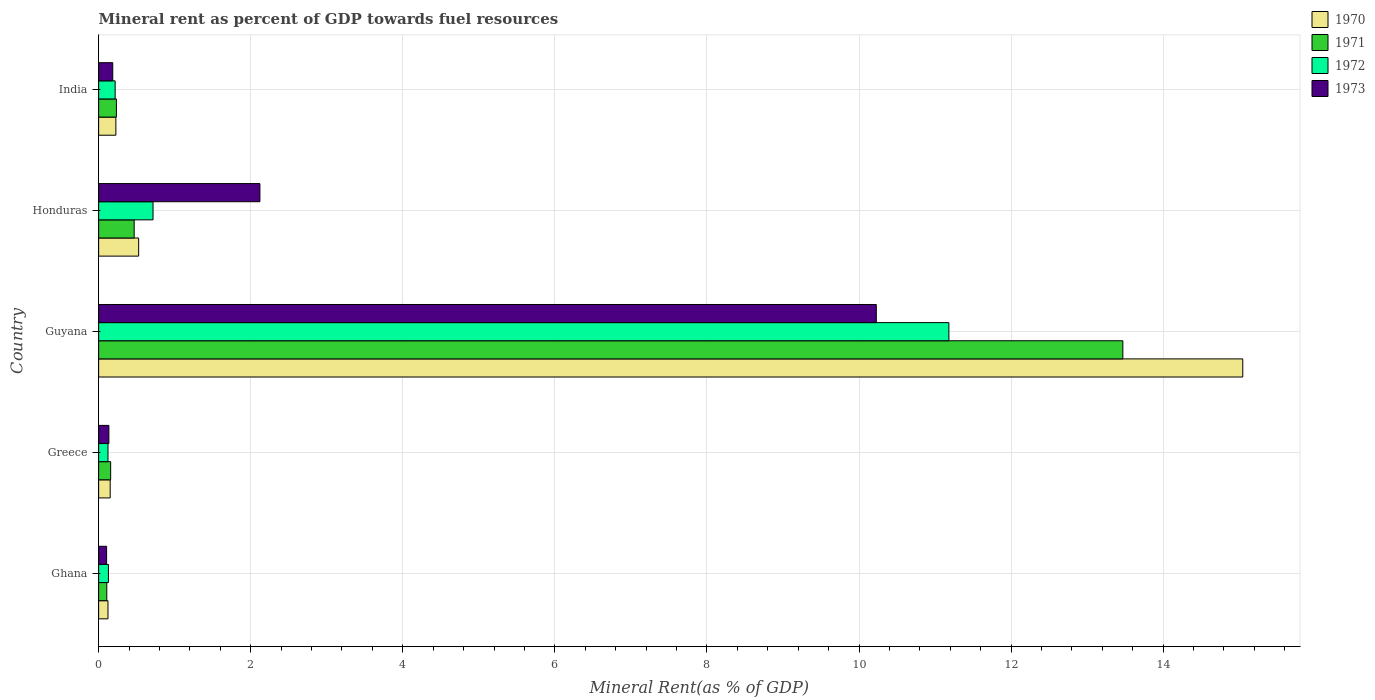How many different coloured bars are there?
Ensure brevity in your answer.  4. How many bars are there on the 4th tick from the top?
Provide a succinct answer. 4. How many bars are there on the 1st tick from the bottom?
Provide a short and direct response. 4. What is the label of the 3rd group of bars from the top?
Keep it short and to the point. Guyana. In how many cases, is the number of bars for a given country not equal to the number of legend labels?
Provide a short and direct response. 0. What is the mineral rent in 1971 in Ghana?
Provide a succinct answer. 0.11. Across all countries, what is the maximum mineral rent in 1972?
Provide a short and direct response. 11.18. Across all countries, what is the minimum mineral rent in 1971?
Offer a very short reply. 0.11. In which country was the mineral rent in 1971 maximum?
Ensure brevity in your answer.  Guyana. In which country was the mineral rent in 1971 minimum?
Provide a succinct answer. Ghana. What is the total mineral rent in 1970 in the graph?
Offer a very short reply. 16.08. What is the difference between the mineral rent in 1970 in Ghana and that in Honduras?
Keep it short and to the point. -0.4. What is the difference between the mineral rent in 1972 in India and the mineral rent in 1970 in Honduras?
Provide a short and direct response. -0.31. What is the average mineral rent in 1972 per country?
Make the answer very short. 2.47. What is the difference between the mineral rent in 1973 and mineral rent in 1970 in Honduras?
Offer a very short reply. 1.59. What is the ratio of the mineral rent in 1973 in Ghana to that in Greece?
Your answer should be very brief. 0.78. What is the difference between the highest and the second highest mineral rent in 1970?
Provide a succinct answer. 14.52. What is the difference between the highest and the lowest mineral rent in 1973?
Your response must be concise. 10.12. In how many countries, is the mineral rent in 1973 greater than the average mineral rent in 1973 taken over all countries?
Offer a terse response. 1. Is the sum of the mineral rent in 1970 in Ghana and Honduras greater than the maximum mineral rent in 1972 across all countries?
Give a very brief answer. No. What does the 3rd bar from the top in Greece represents?
Make the answer very short. 1971. What does the 2nd bar from the bottom in Honduras represents?
Offer a terse response. 1971. Is it the case that in every country, the sum of the mineral rent in 1971 and mineral rent in 1972 is greater than the mineral rent in 1970?
Provide a succinct answer. Yes. How many countries are there in the graph?
Offer a terse response. 5. What is the difference between two consecutive major ticks on the X-axis?
Make the answer very short. 2. Are the values on the major ticks of X-axis written in scientific E-notation?
Your response must be concise. No. Where does the legend appear in the graph?
Ensure brevity in your answer.  Top right. How many legend labels are there?
Provide a succinct answer. 4. What is the title of the graph?
Provide a short and direct response. Mineral rent as percent of GDP towards fuel resources. Does "1971" appear as one of the legend labels in the graph?
Your answer should be very brief. Yes. What is the label or title of the X-axis?
Your answer should be compact. Mineral Rent(as % of GDP). What is the label or title of the Y-axis?
Provide a succinct answer. Country. What is the Mineral Rent(as % of GDP) of 1970 in Ghana?
Provide a succinct answer. 0.12. What is the Mineral Rent(as % of GDP) of 1971 in Ghana?
Your answer should be compact. 0.11. What is the Mineral Rent(as % of GDP) in 1972 in Ghana?
Provide a succinct answer. 0.13. What is the Mineral Rent(as % of GDP) of 1973 in Ghana?
Offer a terse response. 0.1. What is the Mineral Rent(as % of GDP) of 1970 in Greece?
Your answer should be compact. 0.15. What is the Mineral Rent(as % of GDP) in 1971 in Greece?
Give a very brief answer. 0.16. What is the Mineral Rent(as % of GDP) of 1972 in Greece?
Your answer should be very brief. 0.12. What is the Mineral Rent(as % of GDP) in 1973 in Greece?
Offer a terse response. 0.13. What is the Mineral Rent(as % of GDP) in 1970 in Guyana?
Your answer should be compact. 15.05. What is the Mineral Rent(as % of GDP) in 1971 in Guyana?
Ensure brevity in your answer.  13.47. What is the Mineral Rent(as % of GDP) of 1972 in Guyana?
Your response must be concise. 11.18. What is the Mineral Rent(as % of GDP) of 1973 in Guyana?
Your answer should be very brief. 10.23. What is the Mineral Rent(as % of GDP) of 1970 in Honduras?
Ensure brevity in your answer.  0.53. What is the Mineral Rent(as % of GDP) in 1971 in Honduras?
Your answer should be compact. 0.47. What is the Mineral Rent(as % of GDP) in 1972 in Honduras?
Offer a terse response. 0.72. What is the Mineral Rent(as % of GDP) of 1973 in Honduras?
Provide a short and direct response. 2.12. What is the Mineral Rent(as % of GDP) in 1970 in India?
Keep it short and to the point. 0.23. What is the Mineral Rent(as % of GDP) in 1971 in India?
Make the answer very short. 0.23. What is the Mineral Rent(as % of GDP) in 1972 in India?
Keep it short and to the point. 0.22. What is the Mineral Rent(as % of GDP) of 1973 in India?
Your answer should be compact. 0.19. Across all countries, what is the maximum Mineral Rent(as % of GDP) of 1970?
Your answer should be compact. 15.05. Across all countries, what is the maximum Mineral Rent(as % of GDP) in 1971?
Keep it short and to the point. 13.47. Across all countries, what is the maximum Mineral Rent(as % of GDP) in 1972?
Make the answer very short. 11.18. Across all countries, what is the maximum Mineral Rent(as % of GDP) in 1973?
Offer a very short reply. 10.23. Across all countries, what is the minimum Mineral Rent(as % of GDP) of 1970?
Ensure brevity in your answer.  0.12. Across all countries, what is the minimum Mineral Rent(as % of GDP) in 1971?
Ensure brevity in your answer.  0.11. Across all countries, what is the minimum Mineral Rent(as % of GDP) of 1972?
Offer a terse response. 0.12. Across all countries, what is the minimum Mineral Rent(as % of GDP) of 1973?
Your answer should be compact. 0.1. What is the total Mineral Rent(as % of GDP) in 1970 in the graph?
Provide a succinct answer. 16.08. What is the total Mineral Rent(as % of GDP) in 1971 in the graph?
Ensure brevity in your answer.  14.44. What is the total Mineral Rent(as % of GDP) in 1972 in the graph?
Your answer should be compact. 12.37. What is the total Mineral Rent(as % of GDP) in 1973 in the graph?
Provide a short and direct response. 12.77. What is the difference between the Mineral Rent(as % of GDP) of 1970 in Ghana and that in Greece?
Offer a terse response. -0.03. What is the difference between the Mineral Rent(as % of GDP) of 1971 in Ghana and that in Greece?
Provide a short and direct response. -0.05. What is the difference between the Mineral Rent(as % of GDP) of 1972 in Ghana and that in Greece?
Provide a short and direct response. 0.01. What is the difference between the Mineral Rent(as % of GDP) in 1973 in Ghana and that in Greece?
Make the answer very short. -0.03. What is the difference between the Mineral Rent(as % of GDP) of 1970 in Ghana and that in Guyana?
Give a very brief answer. -14.92. What is the difference between the Mineral Rent(as % of GDP) of 1971 in Ghana and that in Guyana?
Provide a succinct answer. -13.36. What is the difference between the Mineral Rent(as % of GDP) of 1972 in Ghana and that in Guyana?
Your response must be concise. -11.05. What is the difference between the Mineral Rent(as % of GDP) of 1973 in Ghana and that in Guyana?
Provide a short and direct response. -10.12. What is the difference between the Mineral Rent(as % of GDP) of 1970 in Ghana and that in Honduras?
Offer a terse response. -0.4. What is the difference between the Mineral Rent(as % of GDP) in 1971 in Ghana and that in Honduras?
Provide a succinct answer. -0.36. What is the difference between the Mineral Rent(as % of GDP) of 1972 in Ghana and that in Honduras?
Provide a succinct answer. -0.59. What is the difference between the Mineral Rent(as % of GDP) of 1973 in Ghana and that in Honduras?
Your answer should be very brief. -2.02. What is the difference between the Mineral Rent(as % of GDP) of 1970 in Ghana and that in India?
Your response must be concise. -0.1. What is the difference between the Mineral Rent(as % of GDP) in 1971 in Ghana and that in India?
Your answer should be compact. -0.13. What is the difference between the Mineral Rent(as % of GDP) in 1972 in Ghana and that in India?
Your answer should be very brief. -0.09. What is the difference between the Mineral Rent(as % of GDP) in 1973 in Ghana and that in India?
Your answer should be compact. -0.08. What is the difference between the Mineral Rent(as % of GDP) of 1970 in Greece and that in Guyana?
Your response must be concise. -14.9. What is the difference between the Mineral Rent(as % of GDP) of 1971 in Greece and that in Guyana?
Provide a succinct answer. -13.31. What is the difference between the Mineral Rent(as % of GDP) in 1972 in Greece and that in Guyana?
Offer a very short reply. -11.06. What is the difference between the Mineral Rent(as % of GDP) of 1973 in Greece and that in Guyana?
Provide a short and direct response. -10.09. What is the difference between the Mineral Rent(as % of GDP) in 1970 in Greece and that in Honduras?
Offer a very short reply. -0.37. What is the difference between the Mineral Rent(as % of GDP) of 1971 in Greece and that in Honduras?
Your answer should be compact. -0.31. What is the difference between the Mineral Rent(as % of GDP) in 1972 in Greece and that in Honduras?
Your answer should be very brief. -0.59. What is the difference between the Mineral Rent(as % of GDP) in 1973 in Greece and that in Honduras?
Offer a terse response. -1.99. What is the difference between the Mineral Rent(as % of GDP) of 1970 in Greece and that in India?
Keep it short and to the point. -0.07. What is the difference between the Mineral Rent(as % of GDP) in 1971 in Greece and that in India?
Offer a terse response. -0.08. What is the difference between the Mineral Rent(as % of GDP) of 1972 in Greece and that in India?
Ensure brevity in your answer.  -0.09. What is the difference between the Mineral Rent(as % of GDP) of 1973 in Greece and that in India?
Provide a succinct answer. -0.05. What is the difference between the Mineral Rent(as % of GDP) in 1970 in Guyana and that in Honduras?
Your response must be concise. 14.52. What is the difference between the Mineral Rent(as % of GDP) of 1971 in Guyana and that in Honduras?
Ensure brevity in your answer.  13. What is the difference between the Mineral Rent(as % of GDP) of 1972 in Guyana and that in Honduras?
Your answer should be very brief. 10.47. What is the difference between the Mineral Rent(as % of GDP) of 1973 in Guyana and that in Honduras?
Ensure brevity in your answer.  8.11. What is the difference between the Mineral Rent(as % of GDP) of 1970 in Guyana and that in India?
Keep it short and to the point. 14.82. What is the difference between the Mineral Rent(as % of GDP) in 1971 in Guyana and that in India?
Give a very brief answer. 13.24. What is the difference between the Mineral Rent(as % of GDP) of 1972 in Guyana and that in India?
Ensure brevity in your answer.  10.96. What is the difference between the Mineral Rent(as % of GDP) of 1973 in Guyana and that in India?
Your answer should be compact. 10.04. What is the difference between the Mineral Rent(as % of GDP) in 1970 in Honduras and that in India?
Ensure brevity in your answer.  0.3. What is the difference between the Mineral Rent(as % of GDP) of 1971 in Honduras and that in India?
Your answer should be very brief. 0.23. What is the difference between the Mineral Rent(as % of GDP) of 1972 in Honduras and that in India?
Offer a very short reply. 0.5. What is the difference between the Mineral Rent(as % of GDP) of 1973 in Honduras and that in India?
Your answer should be compact. 1.94. What is the difference between the Mineral Rent(as % of GDP) of 1970 in Ghana and the Mineral Rent(as % of GDP) of 1971 in Greece?
Offer a terse response. -0.04. What is the difference between the Mineral Rent(as % of GDP) in 1970 in Ghana and the Mineral Rent(as % of GDP) in 1973 in Greece?
Make the answer very short. -0.01. What is the difference between the Mineral Rent(as % of GDP) in 1971 in Ghana and the Mineral Rent(as % of GDP) in 1972 in Greece?
Give a very brief answer. -0.02. What is the difference between the Mineral Rent(as % of GDP) in 1971 in Ghana and the Mineral Rent(as % of GDP) in 1973 in Greece?
Offer a very short reply. -0.03. What is the difference between the Mineral Rent(as % of GDP) in 1972 in Ghana and the Mineral Rent(as % of GDP) in 1973 in Greece?
Provide a succinct answer. -0.01. What is the difference between the Mineral Rent(as % of GDP) of 1970 in Ghana and the Mineral Rent(as % of GDP) of 1971 in Guyana?
Give a very brief answer. -13.35. What is the difference between the Mineral Rent(as % of GDP) of 1970 in Ghana and the Mineral Rent(as % of GDP) of 1972 in Guyana?
Your answer should be compact. -11.06. What is the difference between the Mineral Rent(as % of GDP) in 1970 in Ghana and the Mineral Rent(as % of GDP) in 1973 in Guyana?
Ensure brevity in your answer.  -10.1. What is the difference between the Mineral Rent(as % of GDP) of 1971 in Ghana and the Mineral Rent(as % of GDP) of 1972 in Guyana?
Your answer should be compact. -11.07. What is the difference between the Mineral Rent(as % of GDP) in 1971 in Ghana and the Mineral Rent(as % of GDP) in 1973 in Guyana?
Provide a succinct answer. -10.12. What is the difference between the Mineral Rent(as % of GDP) of 1972 in Ghana and the Mineral Rent(as % of GDP) of 1973 in Guyana?
Ensure brevity in your answer.  -10.1. What is the difference between the Mineral Rent(as % of GDP) of 1970 in Ghana and the Mineral Rent(as % of GDP) of 1971 in Honduras?
Your answer should be compact. -0.34. What is the difference between the Mineral Rent(as % of GDP) in 1970 in Ghana and the Mineral Rent(as % of GDP) in 1972 in Honduras?
Make the answer very short. -0.59. What is the difference between the Mineral Rent(as % of GDP) of 1970 in Ghana and the Mineral Rent(as % of GDP) of 1973 in Honduras?
Give a very brief answer. -2. What is the difference between the Mineral Rent(as % of GDP) of 1971 in Ghana and the Mineral Rent(as % of GDP) of 1972 in Honduras?
Offer a terse response. -0.61. What is the difference between the Mineral Rent(as % of GDP) in 1971 in Ghana and the Mineral Rent(as % of GDP) in 1973 in Honduras?
Offer a terse response. -2.01. What is the difference between the Mineral Rent(as % of GDP) of 1972 in Ghana and the Mineral Rent(as % of GDP) of 1973 in Honduras?
Offer a terse response. -1.99. What is the difference between the Mineral Rent(as % of GDP) of 1970 in Ghana and the Mineral Rent(as % of GDP) of 1971 in India?
Offer a terse response. -0.11. What is the difference between the Mineral Rent(as % of GDP) in 1970 in Ghana and the Mineral Rent(as % of GDP) in 1972 in India?
Your answer should be compact. -0.09. What is the difference between the Mineral Rent(as % of GDP) in 1970 in Ghana and the Mineral Rent(as % of GDP) in 1973 in India?
Your answer should be compact. -0.06. What is the difference between the Mineral Rent(as % of GDP) in 1971 in Ghana and the Mineral Rent(as % of GDP) in 1972 in India?
Provide a short and direct response. -0.11. What is the difference between the Mineral Rent(as % of GDP) in 1971 in Ghana and the Mineral Rent(as % of GDP) in 1973 in India?
Give a very brief answer. -0.08. What is the difference between the Mineral Rent(as % of GDP) in 1972 in Ghana and the Mineral Rent(as % of GDP) in 1973 in India?
Offer a very short reply. -0.06. What is the difference between the Mineral Rent(as % of GDP) of 1970 in Greece and the Mineral Rent(as % of GDP) of 1971 in Guyana?
Your answer should be very brief. -13.32. What is the difference between the Mineral Rent(as % of GDP) of 1970 in Greece and the Mineral Rent(as % of GDP) of 1972 in Guyana?
Keep it short and to the point. -11.03. What is the difference between the Mineral Rent(as % of GDP) of 1970 in Greece and the Mineral Rent(as % of GDP) of 1973 in Guyana?
Your answer should be very brief. -10.08. What is the difference between the Mineral Rent(as % of GDP) of 1971 in Greece and the Mineral Rent(as % of GDP) of 1972 in Guyana?
Offer a very short reply. -11.02. What is the difference between the Mineral Rent(as % of GDP) in 1971 in Greece and the Mineral Rent(as % of GDP) in 1973 in Guyana?
Offer a terse response. -10.07. What is the difference between the Mineral Rent(as % of GDP) in 1972 in Greece and the Mineral Rent(as % of GDP) in 1973 in Guyana?
Your answer should be compact. -10.1. What is the difference between the Mineral Rent(as % of GDP) of 1970 in Greece and the Mineral Rent(as % of GDP) of 1971 in Honduras?
Offer a terse response. -0.32. What is the difference between the Mineral Rent(as % of GDP) in 1970 in Greece and the Mineral Rent(as % of GDP) in 1972 in Honduras?
Keep it short and to the point. -0.56. What is the difference between the Mineral Rent(as % of GDP) in 1970 in Greece and the Mineral Rent(as % of GDP) in 1973 in Honduras?
Ensure brevity in your answer.  -1.97. What is the difference between the Mineral Rent(as % of GDP) in 1971 in Greece and the Mineral Rent(as % of GDP) in 1972 in Honduras?
Your answer should be very brief. -0.56. What is the difference between the Mineral Rent(as % of GDP) in 1971 in Greece and the Mineral Rent(as % of GDP) in 1973 in Honduras?
Provide a succinct answer. -1.96. What is the difference between the Mineral Rent(as % of GDP) in 1972 in Greece and the Mineral Rent(as % of GDP) in 1973 in Honduras?
Provide a short and direct response. -2. What is the difference between the Mineral Rent(as % of GDP) in 1970 in Greece and the Mineral Rent(as % of GDP) in 1971 in India?
Provide a succinct answer. -0.08. What is the difference between the Mineral Rent(as % of GDP) in 1970 in Greece and the Mineral Rent(as % of GDP) in 1972 in India?
Your answer should be compact. -0.07. What is the difference between the Mineral Rent(as % of GDP) of 1970 in Greece and the Mineral Rent(as % of GDP) of 1973 in India?
Provide a succinct answer. -0.03. What is the difference between the Mineral Rent(as % of GDP) in 1971 in Greece and the Mineral Rent(as % of GDP) in 1972 in India?
Provide a succinct answer. -0.06. What is the difference between the Mineral Rent(as % of GDP) in 1971 in Greece and the Mineral Rent(as % of GDP) in 1973 in India?
Your response must be concise. -0.03. What is the difference between the Mineral Rent(as % of GDP) of 1972 in Greece and the Mineral Rent(as % of GDP) of 1973 in India?
Your response must be concise. -0.06. What is the difference between the Mineral Rent(as % of GDP) of 1970 in Guyana and the Mineral Rent(as % of GDP) of 1971 in Honduras?
Provide a short and direct response. 14.58. What is the difference between the Mineral Rent(as % of GDP) of 1970 in Guyana and the Mineral Rent(as % of GDP) of 1972 in Honduras?
Your answer should be compact. 14.33. What is the difference between the Mineral Rent(as % of GDP) of 1970 in Guyana and the Mineral Rent(as % of GDP) of 1973 in Honduras?
Offer a terse response. 12.93. What is the difference between the Mineral Rent(as % of GDP) in 1971 in Guyana and the Mineral Rent(as % of GDP) in 1972 in Honduras?
Your answer should be compact. 12.75. What is the difference between the Mineral Rent(as % of GDP) in 1971 in Guyana and the Mineral Rent(as % of GDP) in 1973 in Honduras?
Keep it short and to the point. 11.35. What is the difference between the Mineral Rent(as % of GDP) in 1972 in Guyana and the Mineral Rent(as % of GDP) in 1973 in Honduras?
Ensure brevity in your answer.  9.06. What is the difference between the Mineral Rent(as % of GDP) in 1970 in Guyana and the Mineral Rent(as % of GDP) in 1971 in India?
Your response must be concise. 14.81. What is the difference between the Mineral Rent(as % of GDP) of 1970 in Guyana and the Mineral Rent(as % of GDP) of 1972 in India?
Provide a succinct answer. 14.83. What is the difference between the Mineral Rent(as % of GDP) in 1970 in Guyana and the Mineral Rent(as % of GDP) in 1973 in India?
Ensure brevity in your answer.  14.86. What is the difference between the Mineral Rent(as % of GDP) in 1971 in Guyana and the Mineral Rent(as % of GDP) in 1972 in India?
Make the answer very short. 13.25. What is the difference between the Mineral Rent(as % of GDP) of 1971 in Guyana and the Mineral Rent(as % of GDP) of 1973 in India?
Provide a short and direct response. 13.28. What is the difference between the Mineral Rent(as % of GDP) in 1972 in Guyana and the Mineral Rent(as % of GDP) in 1973 in India?
Make the answer very short. 11. What is the difference between the Mineral Rent(as % of GDP) in 1970 in Honduras and the Mineral Rent(as % of GDP) in 1971 in India?
Keep it short and to the point. 0.29. What is the difference between the Mineral Rent(as % of GDP) of 1970 in Honduras and the Mineral Rent(as % of GDP) of 1972 in India?
Make the answer very short. 0.31. What is the difference between the Mineral Rent(as % of GDP) in 1970 in Honduras and the Mineral Rent(as % of GDP) in 1973 in India?
Your answer should be very brief. 0.34. What is the difference between the Mineral Rent(as % of GDP) in 1971 in Honduras and the Mineral Rent(as % of GDP) in 1972 in India?
Your answer should be compact. 0.25. What is the difference between the Mineral Rent(as % of GDP) in 1971 in Honduras and the Mineral Rent(as % of GDP) in 1973 in India?
Provide a short and direct response. 0.28. What is the difference between the Mineral Rent(as % of GDP) of 1972 in Honduras and the Mineral Rent(as % of GDP) of 1973 in India?
Keep it short and to the point. 0.53. What is the average Mineral Rent(as % of GDP) of 1970 per country?
Offer a very short reply. 3.22. What is the average Mineral Rent(as % of GDP) in 1971 per country?
Your answer should be very brief. 2.89. What is the average Mineral Rent(as % of GDP) in 1972 per country?
Your answer should be very brief. 2.47. What is the average Mineral Rent(as % of GDP) of 1973 per country?
Ensure brevity in your answer.  2.55. What is the difference between the Mineral Rent(as % of GDP) in 1970 and Mineral Rent(as % of GDP) in 1971 in Ghana?
Offer a terse response. 0.02. What is the difference between the Mineral Rent(as % of GDP) of 1970 and Mineral Rent(as % of GDP) of 1972 in Ghana?
Keep it short and to the point. -0.01. What is the difference between the Mineral Rent(as % of GDP) in 1970 and Mineral Rent(as % of GDP) in 1973 in Ghana?
Your response must be concise. 0.02. What is the difference between the Mineral Rent(as % of GDP) in 1971 and Mineral Rent(as % of GDP) in 1972 in Ghana?
Provide a short and direct response. -0.02. What is the difference between the Mineral Rent(as % of GDP) of 1971 and Mineral Rent(as % of GDP) of 1973 in Ghana?
Your answer should be very brief. 0. What is the difference between the Mineral Rent(as % of GDP) of 1972 and Mineral Rent(as % of GDP) of 1973 in Ghana?
Your answer should be compact. 0.02. What is the difference between the Mineral Rent(as % of GDP) in 1970 and Mineral Rent(as % of GDP) in 1971 in Greece?
Provide a succinct answer. -0.01. What is the difference between the Mineral Rent(as % of GDP) of 1970 and Mineral Rent(as % of GDP) of 1972 in Greece?
Give a very brief answer. 0.03. What is the difference between the Mineral Rent(as % of GDP) of 1970 and Mineral Rent(as % of GDP) of 1973 in Greece?
Keep it short and to the point. 0.02. What is the difference between the Mineral Rent(as % of GDP) of 1971 and Mineral Rent(as % of GDP) of 1972 in Greece?
Ensure brevity in your answer.  0.04. What is the difference between the Mineral Rent(as % of GDP) in 1971 and Mineral Rent(as % of GDP) in 1973 in Greece?
Give a very brief answer. 0.02. What is the difference between the Mineral Rent(as % of GDP) in 1972 and Mineral Rent(as % of GDP) in 1973 in Greece?
Offer a very short reply. -0.01. What is the difference between the Mineral Rent(as % of GDP) in 1970 and Mineral Rent(as % of GDP) in 1971 in Guyana?
Your answer should be very brief. 1.58. What is the difference between the Mineral Rent(as % of GDP) in 1970 and Mineral Rent(as % of GDP) in 1972 in Guyana?
Your answer should be very brief. 3.87. What is the difference between the Mineral Rent(as % of GDP) of 1970 and Mineral Rent(as % of GDP) of 1973 in Guyana?
Give a very brief answer. 4.82. What is the difference between the Mineral Rent(as % of GDP) of 1971 and Mineral Rent(as % of GDP) of 1972 in Guyana?
Provide a succinct answer. 2.29. What is the difference between the Mineral Rent(as % of GDP) of 1971 and Mineral Rent(as % of GDP) of 1973 in Guyana?
Provide a succinct answer. 3.24. What is the difference between the Mineral Rent(as % of GDP) of 1972 and Mineral Rent(as % of GDP) of 1973 in Guyana?
Your answer should be compact. 0.95. What is the difference between the Mineral Rent(as % of GDP) of 1970 and Mineral Rent(as % of GDP) of 1971 in Honduras?
Provide a succinct answer. 0.06. What is the difference between the Mineral Rent(as % of GDP) of 1970 and Mineral Rent(as % of GDP) of 1972 in Honduras?
Offer a very short reply. -0.19. What is the difference between the Mineral Rent(as % of GDP) of 1970 and Mineral Rent(as % of GDP) of 1973 in Honduras?
Your answer should be very brief. -1.59. What is the difference between the Mineral Rent(as % of GDP) of 1971 and Mineral Rent(as % of GDP) of 1972 in Honduras?
Offer a terse response. -0.25. What is the difference between the Mineral Rent(as % of GDP) in 1971 and Mineral Rent(as % of GDP) in 1973 in Honduras?
Your response must be concise. -1.65. What is the difference between the Mineral Rent(as % of GDP) of 1972 and Mineral Rent(as % of GDP) of 1973 in Honduras?
Ensure brevity in your answer.  -1.41. What is the difference between the Mineral Rent(as % of GDP) of 1970 and Mineral Rent(as % of GDP) of 1971 in India?
Offer a very short reply. -0.01. What is the difference between the Mineral Rent(as % of GDP) of 1970 and Mineral Rent(as % of GDP) of 1972 in India?
Your answer should be compact. 0.01. What is the difference between the Mineral Rent(as % of GDP) of 1970 and Mineral Rent(as % of GDP) of 1973 in India?
Keep it short and to the point. 0.04. What is the difference between the Mineral Rent(as % of GDP) of 1971 and Mineral Rent(as % of GDP) of 1972 in India?
Make the answer very short. 0.02. What is the difference between the Mineral Rent(as % of GDP) in 1971 and Mineral Rent(as % of GDP) in 1973 in India?
Make the answer very short. 0.05. What is the difference between the Mineral Rent(as % of GDP) in 1972 and Mineral Rent(as % of GDP) in 1973 in India?
Your response must be concise. 0.03. What is the ratio of the Mineral Rent(as % of GDP) in 1970 in Ghana to that in Greece?
Your answer should be compact. 0.81. What is the ratio of the Mineral Rent(as % of GDP) in 1971 in Ghana to that in Greece?
Offer a terse response. 0.68. What is the ratio of the Mineral Rent(as % of GDP) of 1972 in Ghana to that in Greece?
Provide a short and direct response. 1.05. What is the ratio of the Mineral Rent(as % of GDP) of 1973 in Ghana to that in Greece?
Provide a short and direct response. 0.78. What is the ratio of the Mineral Rent(as % of GDP) of 1970 in Ghana to that in Guyana?
Offer a terse response. 0.01. What is the ratio of the Mineral Rent(as % of GDP) in 1971 in Ghana to that in Guyana?
Keep it short and to the point. 0.01. What is the ratio of the Mineral Rent(as % of GDP) of 1972 in Ghana to that in Guyana?
Your answer should be very brief. 0.01. What is the ratio of the Mineral Rent(as % of GDP) of 1973 in Ghana to that in Guyana?
Your response must be concise. 0.01. What is the ratio of the Mineral Rent(as % of GDP) in 1970 in Ghana to that in Honduras?
Give a very brief answer. 0.23. What is the ratio of the Mineral Rent(as % of GDP) in 1971 in Ghana to that in Honduras?
Offer a terse response. 0.23. What is the ratio of the Mineral Rent(as % of GDP) of 1972 in Ghana to that in Honduras?
Keep it short and to the point. 0.18. What is the ratio of the Mineral Rent(as % of GDP) in 1973 in Ghana to that in Honduras?
Provide a short and direct response. 0.05. What is the ratio of the Mineral Rent(as % of GDP) in 1970 in Ghana to that in India?
Provide a succinct answer. 0.54. What is the ratio of the Mineral Rent(as % of GDP) of 1971 in Ghana to that in India?
Give a very brief answer. 0.46. What is the ratio of the Mineral Rent(as % of GDP) of 1972 in Ghana to that in India?
Make the answer very short. 0.59. What is the ratio of the Mineral Rent(as % of GDP) of 1973 in Ghana to that in India?
Give a very brief answer. 0.56. What is the ratio of the Mineral Rent(as % of GDP) in 1970 in Greece to that in Guyana?
Provide a short and direct response. 0.01. What is the ratio of the Mineral Rent(as % of GDP) in 1971 in Greece to that in Guyana?
Your answer should be compact. 0.01. What is the ratio of the Mineral Rent(as % of GDP) in 1972 in Greece to that in Guyana?
Your answer should be very brief. 0.01. What is the ratio of the Mineral Rent(as % of GDP) in 1973 in Greece to that in Guyana?
Keep it short and to the point. 0.01. What is the ratio of the Mineral Rent(as % of GDP) of 1970 in Greece to that in Honduras?
Provide a succinct answer. 0.29. What is the ratio of the Mineral Rent(as % of GDP) in 1971 in Greece to that in Honduras?
Offer a terse response. 0.34. What is the ratio of the Mineral Rent(as % of GDP) of 1972 in Greece to that in Honduras?
Your answer should be very brief. 0.17. What is the ratio of the Mineral Rent(as % of GDP) of 1973 in Greece to that in Honduras?
Your response must be concise. 0.06. What is the ratio of the Mineral Rent(as % of GDP) of 1970 in Greece to that in India?
Ensure brevity in your answer.  0.67. What is the ratio of the Mineral Rent(as % of GDP) in 1971 in Greece to that in India?
Your response must be concise. 0.68. What is the ratio of the Mineral Rent(as % of GDP) of 1972 in Greece to that in India?
Offer a very short reply. 0.57. What is the ratio of the Mineral Rent(as % of GDP) of 1973 in Greece to that in India?
Give a very brief answer. 0.73. What is the ratio of the Mineral Rent(as % of GDP) in 1970 in Guyana to that in Honduras?
Provide a short and direct response. 28.59. What is the ratio of the Mineral Rent(as % of GDP) of 1971 in Guyana to that in Honduras?
Your answer should be compact. 28.82. What is the ratio of the Mineral Rent(as % of GDP) in 1972 in Guyana to that in Honduras?
Offer a terse response. 15.63. What is the ratio of the Mineral Rent(as % of GDP) in 1973 in Guyana to that in Honduras?
Provide a succinct answer. 4.82. What is the ratio of the Mineral Rent(as % of GDP) in 1970 in Guyana to that in India?
Give a very brief answer. 66.33. What is the ratio of the Mineral Rent(as % of GDP) in 1971 in Guyana to that in India?
Provide a short and direct response. 57.65. What is the ratio of the Mineral Rent(as % of GDP) of 1972 in Guyana to that in India?
Your answer should be compact. 51.44. What is the ratio of the Mineral Rent(as % of GDP) of 1973 in Guyana to that in India?
Provide a short and direct response. 55. What is the ratio of the Mineral Rent(as % of GDP) in 1970 in Honduras to that in India?
Ensure brevity in your answer.  2.32. What is the ratio of the Mineral Rent(as % of GDP) of 1971 in Honduras to that in India?
Offer a terse response. 2. What is the ratio of the Mineral Rent(as % of GDP) in 1972 in Honduras to that in India?
Your answer should be compact. 3.29. What is the ratio of the Mineral Rent(as % of GDP) of 1973 in Honduras to that in India?
Give a very brief answer. 11.41. What is the difference between the highest and the second highest Mineral Rent(as % of GDP) of 1970?
Keep it short and to the point. 14.52. What is the difference between the highest and the second highest Mineral Rent(as % of GDP) of 1971?
Give a very brief answer. 13. What is the difference between the highest and the second highest Mineral Rent(as % of GDP) of 1972?
Your answer should be compact. 10.47. What is the difference between the highest and the second highest Mineral Rent(as % of GDP) in 1973?
Ensure brevity in your answer.  8.11. What is the difference between the highest and the lowest Mineral Rent(as % of GDP) of 1970?
Make the answer very short. 14.92. What is the difference between the highest and the lowest Mineral Rent(as % of GDP) of 1971?
Keep it short and to the point. 13.36. What is the difference between the highest and the lowest Mineral Rent(as % of GDP) in 1972?
Offer a very short reply. 11.06. What is the difference between the highest and the lowest Mineral Rent(as % of GDP) of 1973?
Offer a very short reply. 10.12. 